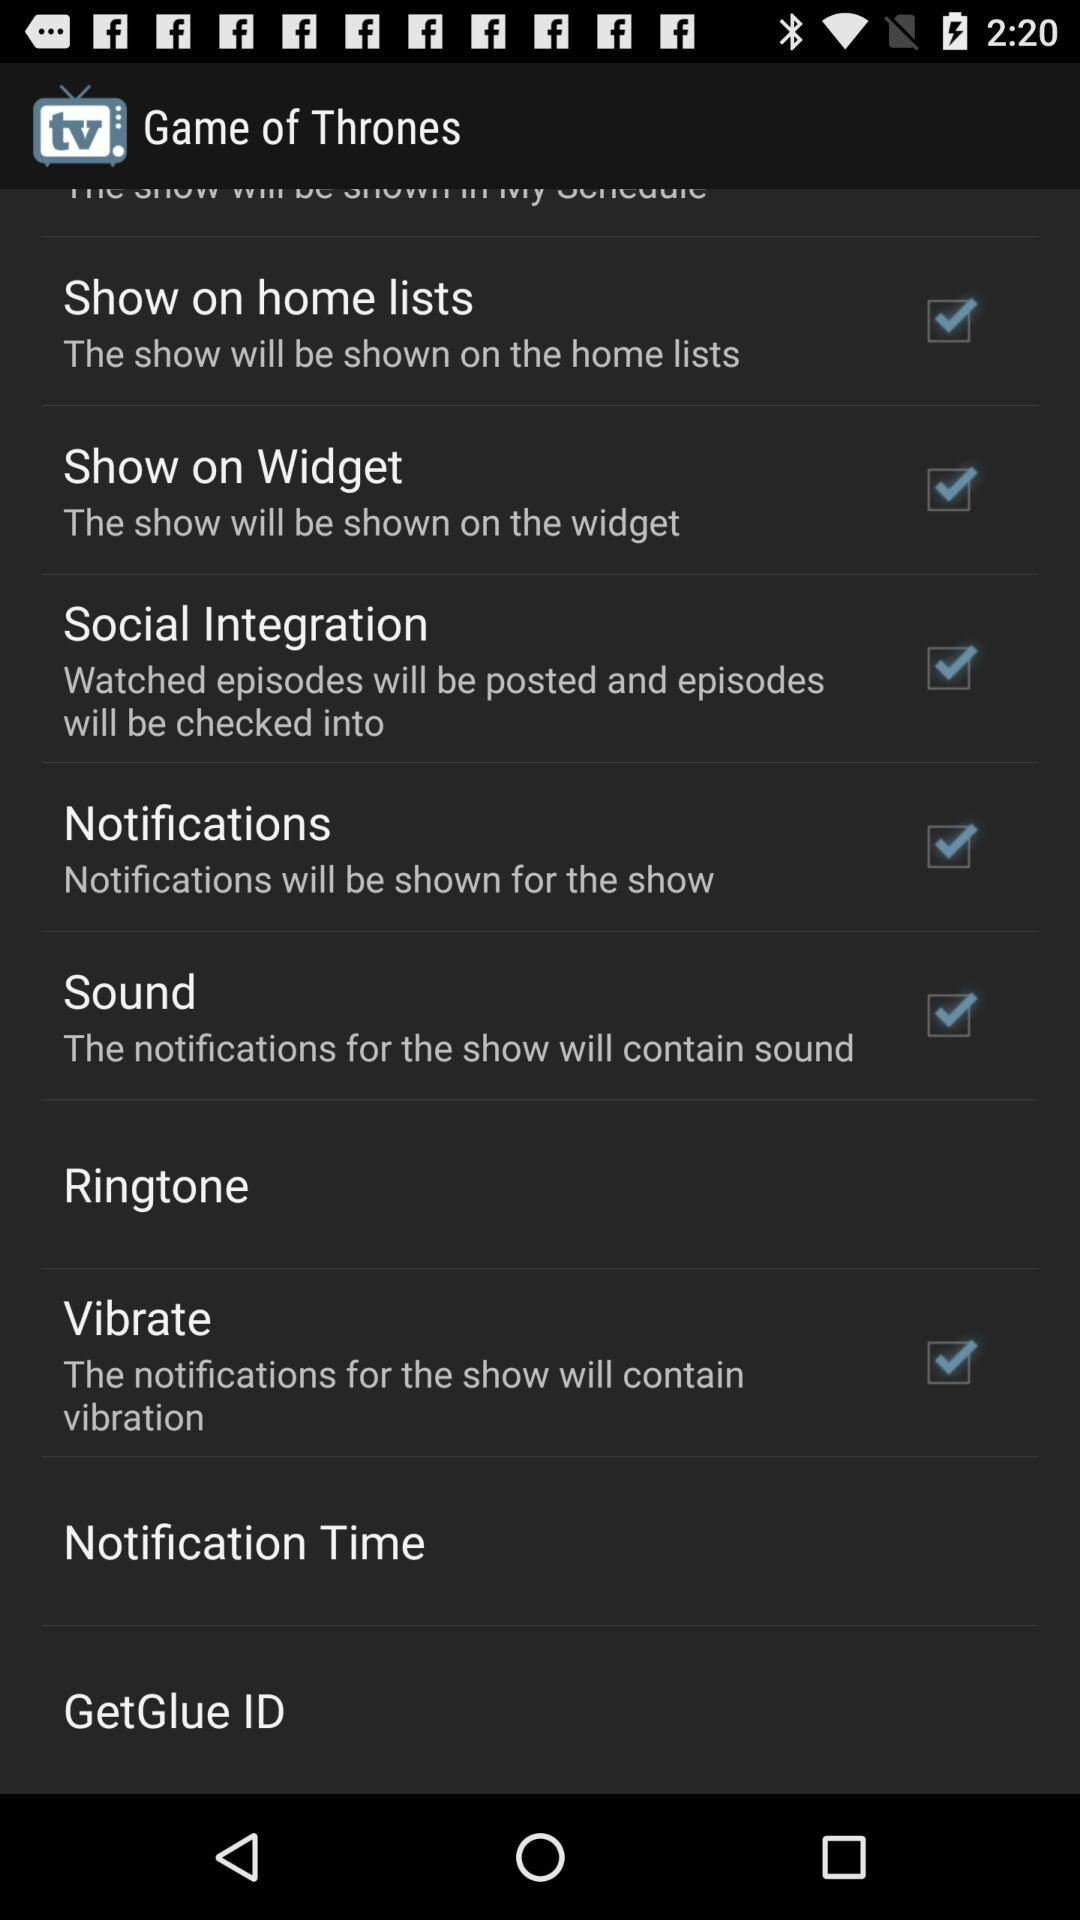What are the checked notification options? The checked notification options are "Show on home lists", "Show on Widget", "Social Integration", "Notifications", "Sound" and "Vibrate". 